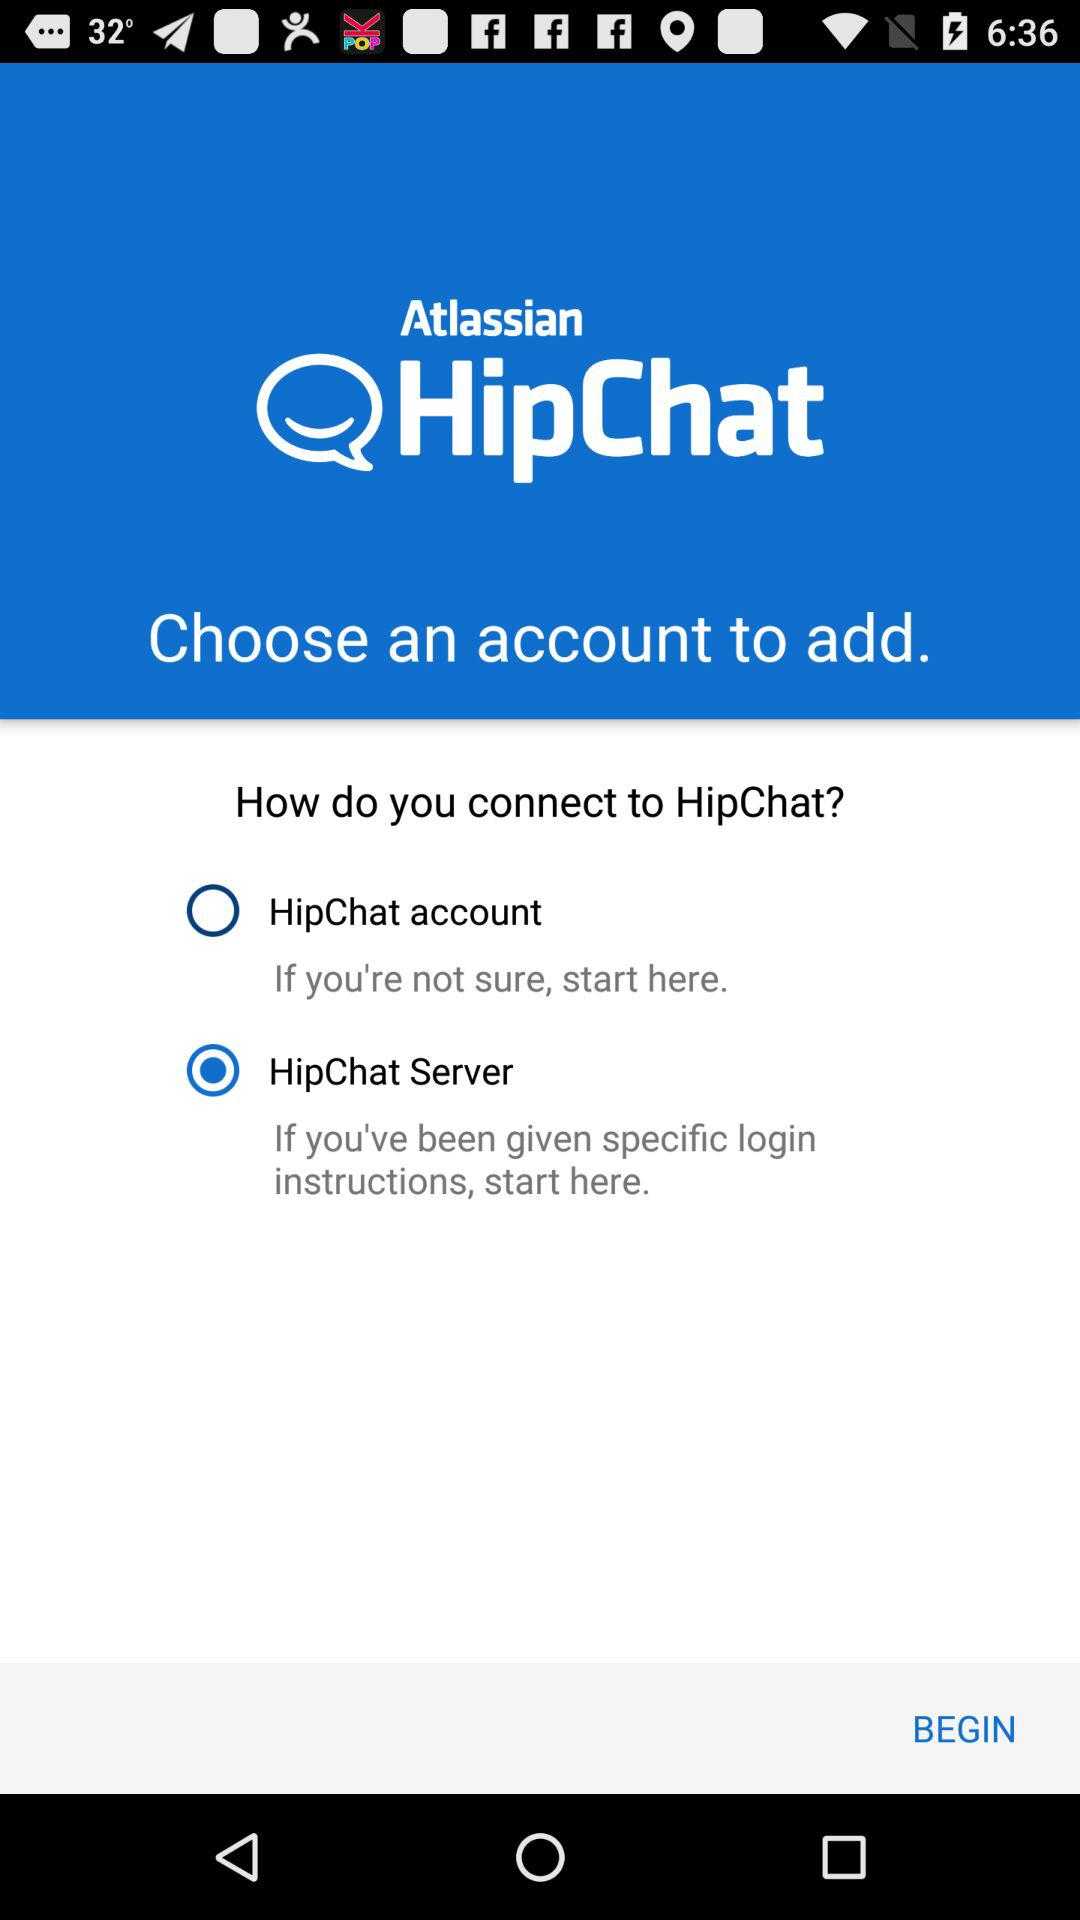How can I connect to "HipChat"? You can connect to "HipChat" through "HipChat account" and "HipChat Server". 